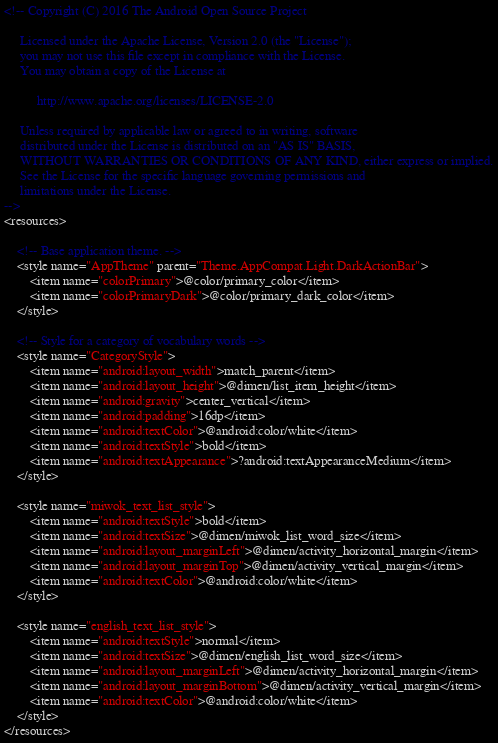<code> <loc_0><loc_0><loc_500><loc_500><_XML_><!-- Copyright (C) 2016 The Android Open Source Project

     Licensed under the Apache License, Version 2.0 (the "License");
     you may not use this file except in compliance with the License.
     You may obtain a copy of the License at

          http://www.apache.org/licenses/LICENSE-2.0

     Unless required by applicable law or agreed to in writing, software
     distributed under the License is distributed on an "AS IS" BASIS,
     WITHOUT WARRANTIES OR CONDITIONS OF ANY KIND, either express or implied.
     See the License for the specific language governing permissions and
     limitations under the License.
-->
<resources>

    <!-- Base application theme. -->
    <style name="AppTheme" parent="Theme.AppCompat.Light.DarkActionBar">
        <item name="colorPrimary">@color/primary_color</item>
        <item name="colorPrimaryDark">@color/primary_dark_color</item>
    </style>

    <!-- Style for a category of vocabulary words -->
    <style name="CategoryStyle">
        <item name="android:layout_width">match_parent</item>
        <item name="android:layout_height">@dimen/list_item_height</item>
        <item name="android:gravity">center_vertical</item>
        <item name="android:padding">16dp</item>
        <item name="android:textColor">@android:color/white</item>
        <item name="android:textStyle">bold</item>
        <item name="android:textAppearance">?android:textAppearanceMedium</item>
    </style>

    <style name="miwok_text_list_style">
        <item name="android:textStyle">bold</item>
        <item name="android:textSize">@dimen/miwok_list_word_size</item>
        <item name="android:layout_marginLeft">@dimen/activity_horizontal_margin</item>
        <item name="android:layout_marginTop">@dimen/activity_vertical_margin</item>
        <item name="android:textColor">@android:color/white</item>
    </style>

    <style name="english_text_list_style">
        <item name="android:textStyle">normal</item>
        <item name="android:textSize">@dimen/english_list_word_size</item>
        <item name="android:layout_marginLeft">@dimen/activity_horizontal_margin</item>
        <item name="android:layout_marginBottom">@dimen/activity_vertical_margin</item>
        <item name="android:textColor">@android:color/white</item>
    </style>
</resources>
</code> 